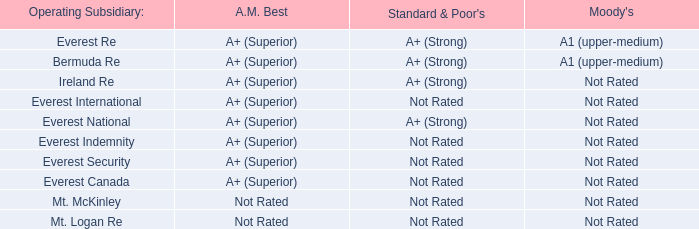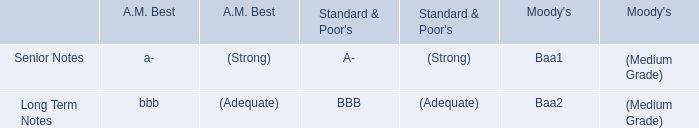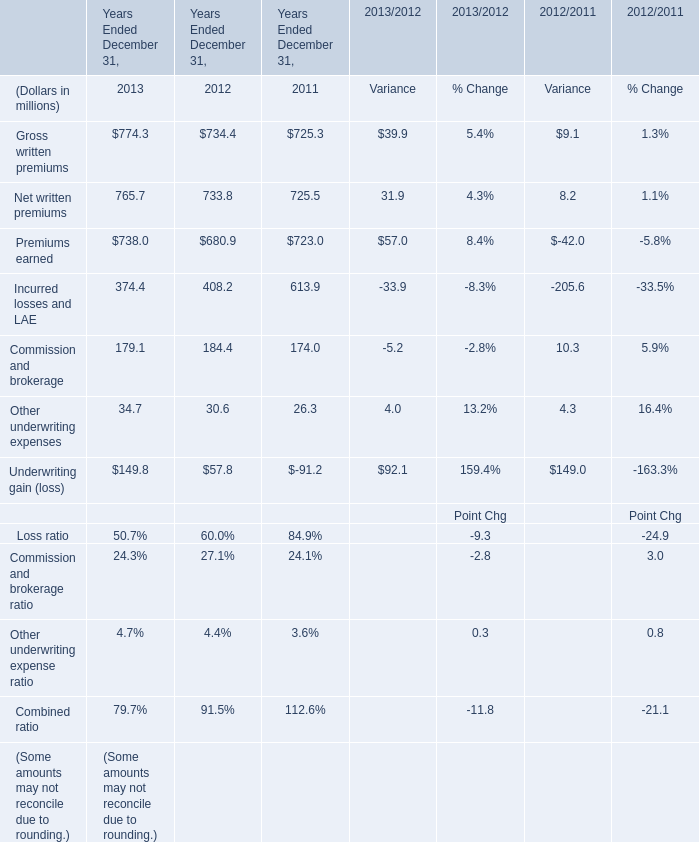What is the sum of the Other underwriting expenses in the years where Gross written premiums greater than 700? (in million) 
Computations: ((34.7 + 30.6) + 26.3)
Answer: 91.6. 